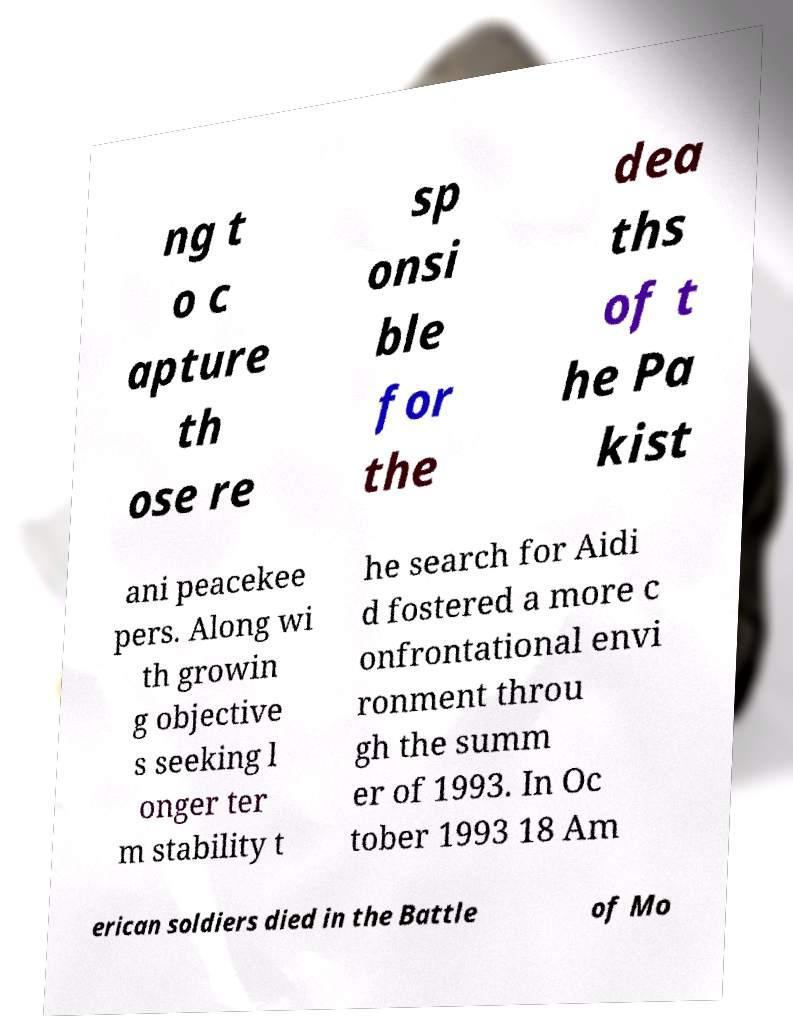Could you extract and type out the text from this image? ng t o c apture th ose re sp onsi ble for the dea ths of t he Pa kist ani peacekee pers. Along wi th growin g objective s seeking l onger ter m stability t he search for Aidi d fostered a more c onfrontational envi ronment throu gh the summ er of 1993. In Oc tober 1993 18 Am erican soldiers died in the Battle of Mo 